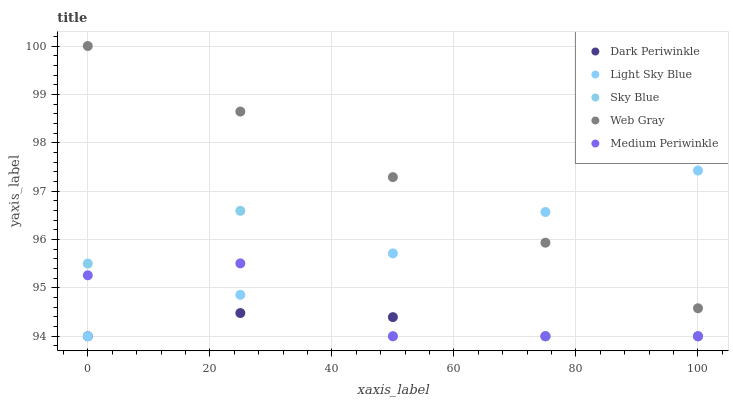Does Dark Periwinkle have the minimum area under the curve?
Answer yes or no. Yes. Does Web Gray have the maximum area under the curve?
Answer yes or no. Yes. Does Light Sky Blue have the minimum area under the curve?
Answer yes or no. No. Does Light Sky Blue have the maximum area under the curve?
Answer yes or no. No. Is Web Gray the smoothest?
Answer yes or no. Yes. Is Sky Blue the roughest?
Answer yes or no. Yes. Is Light Sky Blue the smoothest?
Answer yes or no. No. Is Light Sky Blue the roughest?
Answer yes or no. No. Does Sky Blue have the lowest value?
Answer yes or no. Yes. Does Web Gray have the lowest value?
Answer yes or no. No. Does Web Gray have the highest value?
Answer yes or no. Yes. Does Light Sky Blue have the highest value?
Answer yes or no. No. Is Dark Periwinkle less than Web Gray?
Answer yes or no. Yes. Is Web Gray greater than Medium Periwinkle?
Answer yes or no. Yes. Does Light Sky Blue intersect Dark Periwinkle?
Answer yes or no. Yes. Is Light Sky Blue less than Dark Periwinkle?
Answer yes or no. No. Is Light Sky Blue greater than Dark Periwinkle?
Answer yes or no. No. Does Dark Periwinkle intersect Web Gray?
Answer yes or no. No. 